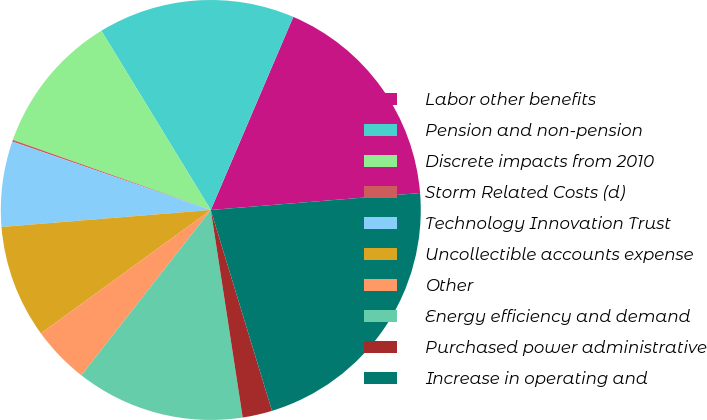Convert chart. <chart><loc_0><loc_0><loc_500><loc_500><pie_chart><fcel>Labor other benefits<fcel>Pension and non-pension<fcel>Discrete impacts from 2010<fcel>Storm Related Costs (d)<fcel>Technology Innovation Trust<fcel>Uncollectible accounts expense<fcel>Other<fcel>Energy efficiency and demand<fcel>Purchased power administrative<fcel>Increase in operating and<nl><fcel>17.29%<fcel>15.15%<fcel>10.86%<fcel>0.14%<fcel>6.57%<fcel>8.71%<fcel>4.43%<fcel>13.0%<fcel>2.28%<fcel>21.58%<nl></chart> 